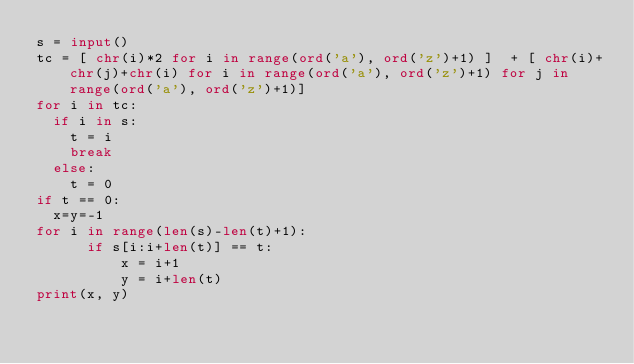Convert code to text. <code><loc_0><loc_0><loc_500><loc_500><_Python_>s = input()
tc = [ chr(i)*2 for i in range(ord('a'), ord('z')+1) ]  + [ chr(i)+chr(j)+chr(i) for i in range(ord('a'), ord('z')+1) for j in range(ord('a'), ord('z')+1)]
for i in tc:
  if i in s:
    t = i
    break
  else:
    t = 0
if t == 0:
  x=y=-1
for i in range(len(s)-len(t)+1):
      if s[i:i+len(t)] == t:
          x = i+1
          y = i+len(t)
print(x, y)</code> 